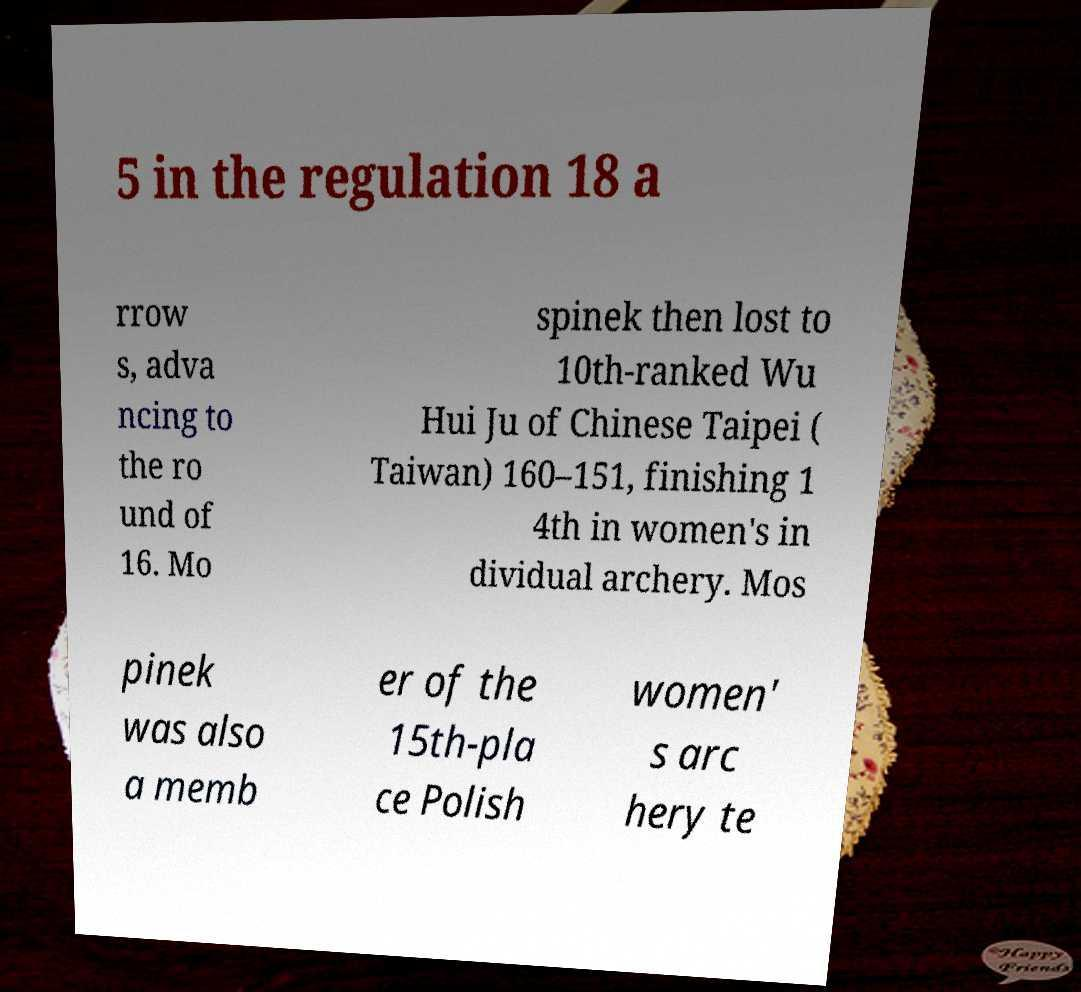Can you accurately transcribe the text from the provided image for me? 5 in the regulation 18 a rrow s, adva ncing to the ro und of 16. Mo spinek then lost to 10th-ranked Wu Hui Ju of Chinese Taipei ( Taiwan) 160–151, finishing 1 4th in women's in dividual archery. Mos pinek was also a memb er of the 15th-pla ce Polish women' s arc hery te 